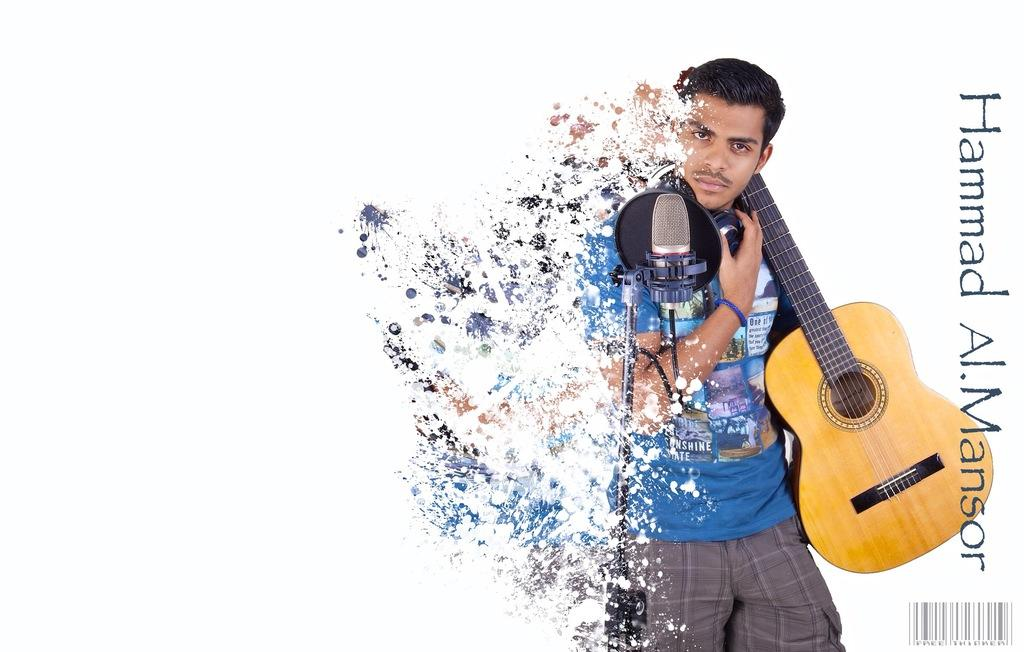What is depicted on the poster in the image? The poster features a person in the image. What is the person holding in the poster? The person is holding a guitar in the poster. What object is the person standing near in the poster? The person is standing in front of a microphone in the poster. What type of coat is the boy wearing in the image? There is no boy present in the image; it features a person holding a guitar and standing in front of a microphone. 